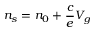Convert formula to latex. <formula><loc_0><loc_0><loc_500><loc_500>n _ { s } = n _ { 0 } + \frac { c } { e } V _ { g }</formula> 